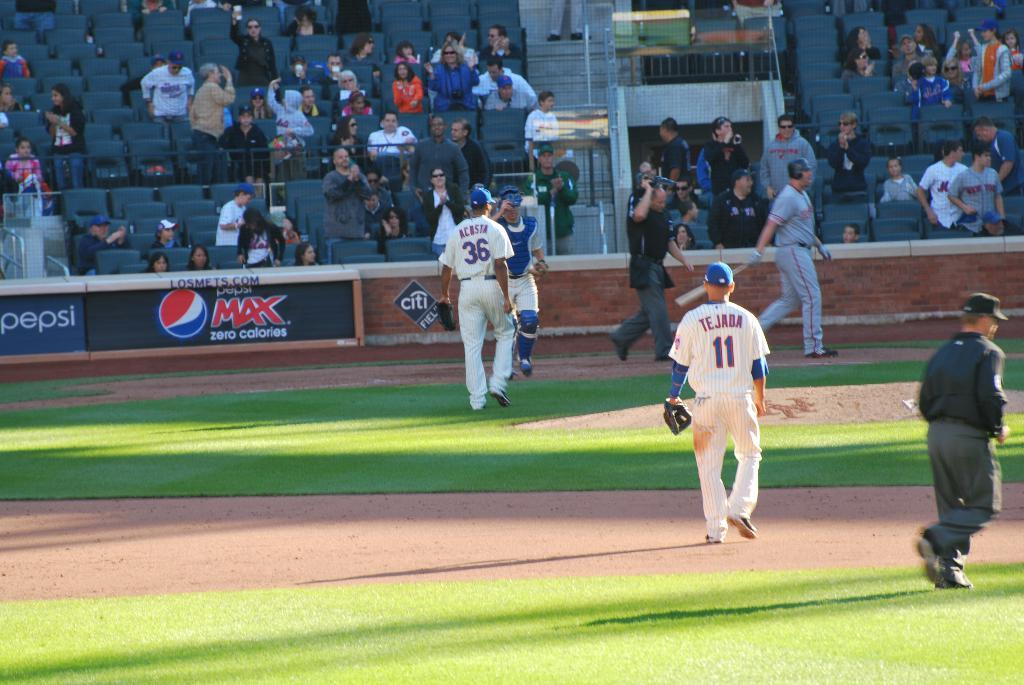<image>
Offer a succinct explanation of the picture presented. Pepsi is a huge sponsor of the baseball team. 